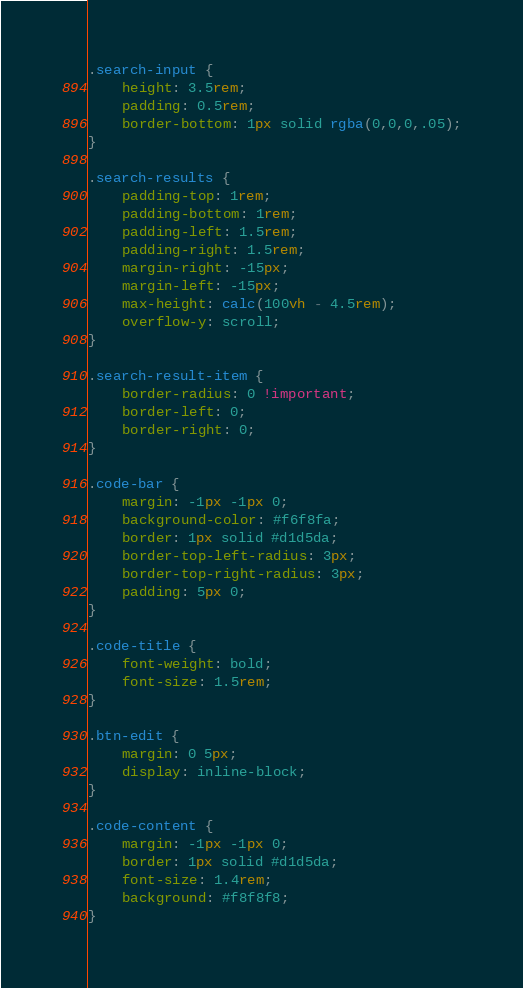<code> <loc_0><loc_0><loc_500><loc_500><_CSS_>.search-input {
    height: 3.5rem;
    padding: 0.5rem;
    border-bottom: 1px solid rgba(0,0,0,.05);
}

.search-results {
    padding-top: 1rem;
    padding-bottom: 1rem;
    padding-left: 1.5rem;
    padding-right: 1.5rem;
    margin-right: -15px;
    margin-left: -15px;
    max-height: calc(100vh - 4.5rem);
    overflow-y: scroll;
}

.search-result-item {
    border-radius: 0 !important;
    border-left: 0;
    border-right: 0;
}

.code-bar {
    margin: -1px -1px 0;
    background-color: #f6f8fa;
    border: 1px solid #d1d5da;
    border-top-left-radius: 3px;
    border-top-right-radius: 3px;
    padding: 5px 0;
}

.code-title {
    font-weight: bold;
    font-size: 1.5rem;
}

.btn-edit {
    margin: 0 5px;
    display: inline-block;
}

.code-content {
    margin: -1px -1px 0;
    border: 1px solid #d1d5da; 
    font-size: 1.4rem;
    background: #f8f8f8;
}
</code> 